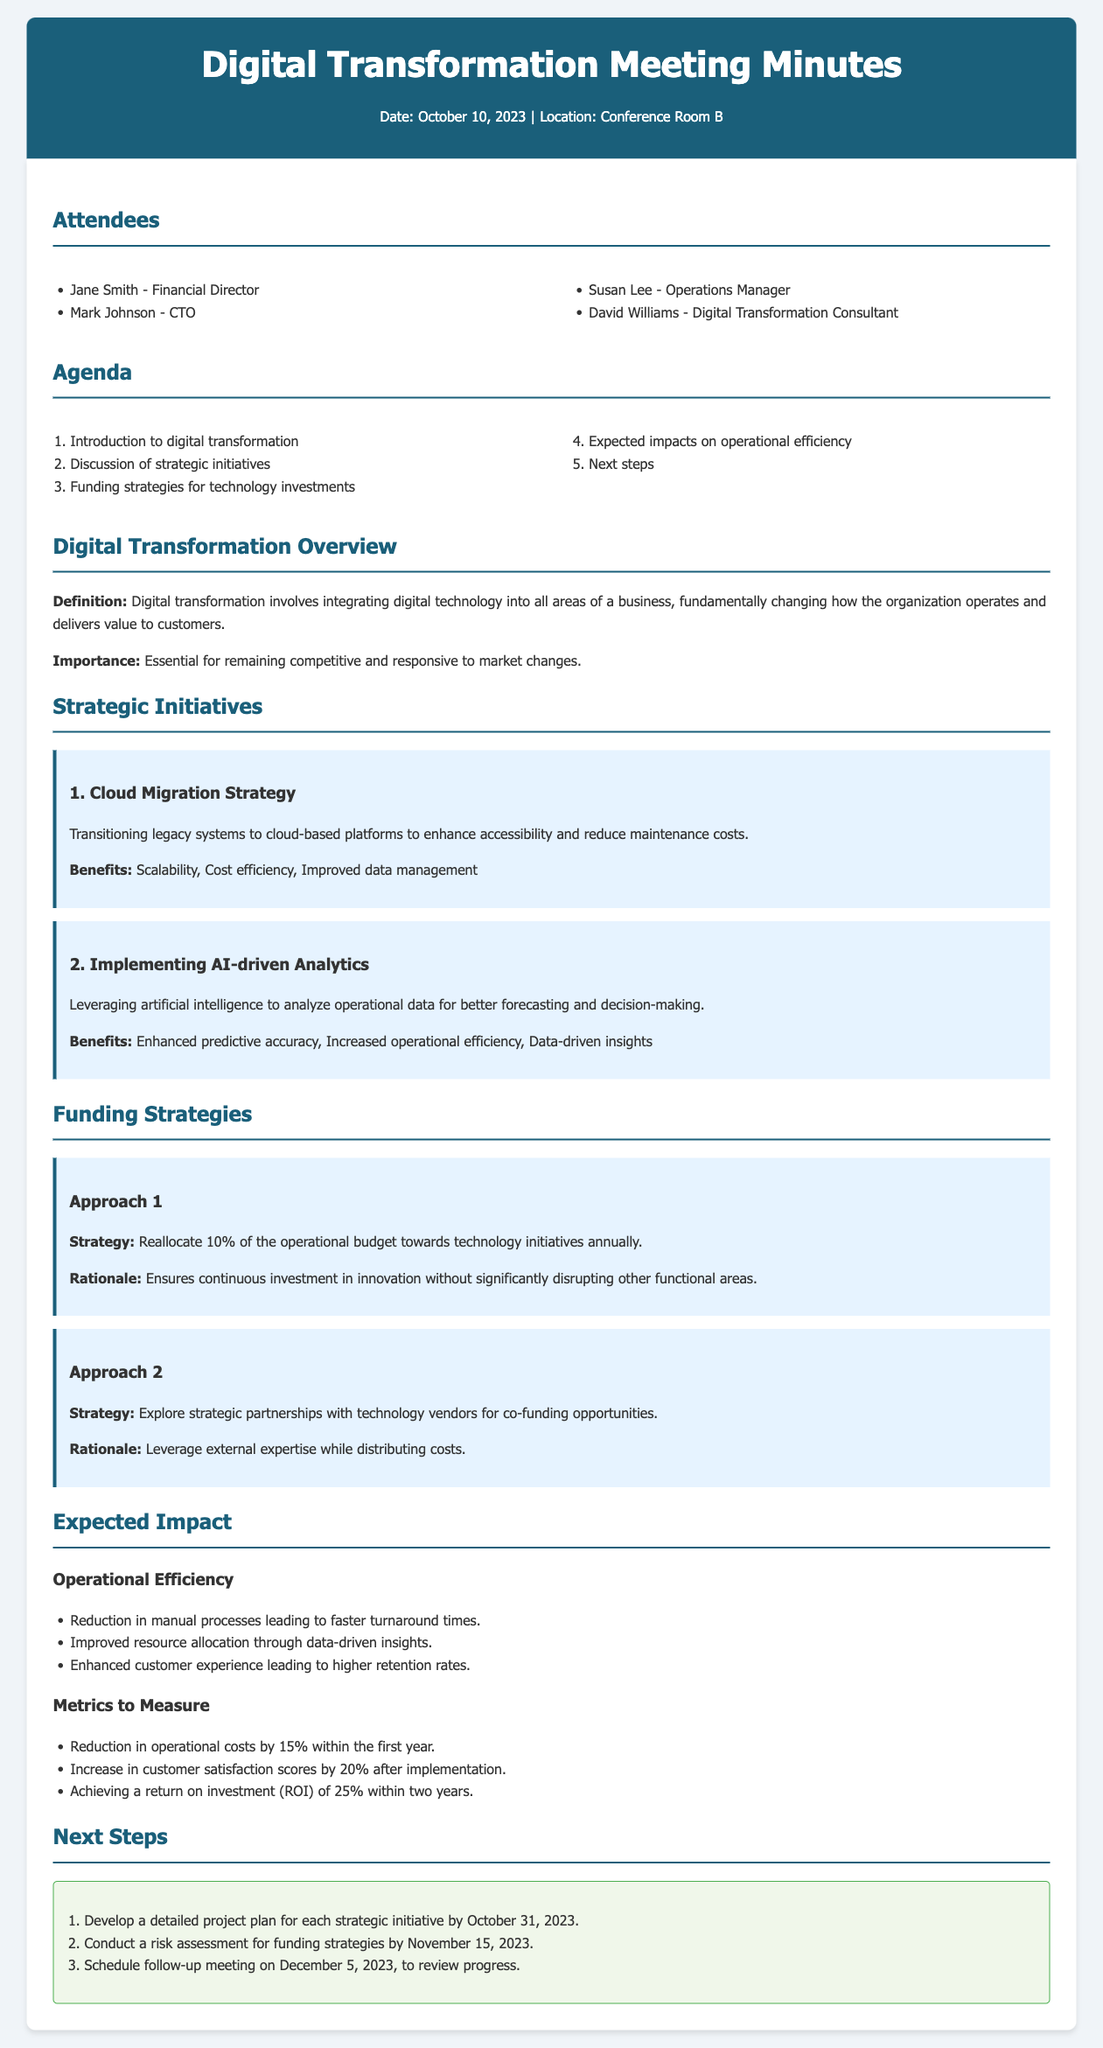What date did the meeting take place? The meeting took place on October 10, 2023, as stated in the document header.
Answer: October 10, 2023 Who is the Financial Director? The document lists Jane Smith as the Financial Director among the attendees.
Answer: Jane Smith What is the first strategic initiative discussed? The first strategic initiative listed in the document is the Cloud Migration Strategy.
Answer: Cloud Migration Strategy What percentage of the operational budget is proposed for reallocation? The proposal suggests reallocating 10% of the operational budget towards technology initiatives annually.
Answer: 10% What is the expected reduction in operational costs within the first year? The document states that the expected reduction in operational costs is by 15% within the first year.
Answer: 15% Which metric measures customer satisfaction after implementation? The document mentions an increase in customer satisfaction scores by 20% after implementation as a metric.
Answer: 20% What is the follow-up meeting date scheduled for? The follow-up meeting is scheduled for December 5, 2023, according to the next steps section.
Answer: December 5, 2023 What external strategy is proposed for funding opportunities? The document suggests exploring strategic partnerships with technology vendors for co-funding opportunities.
Answer: Strategic partnerships with technology vendors 